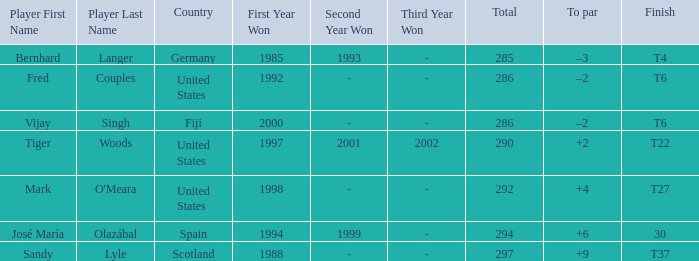What is the total of Mark O'meara? 292.0. 